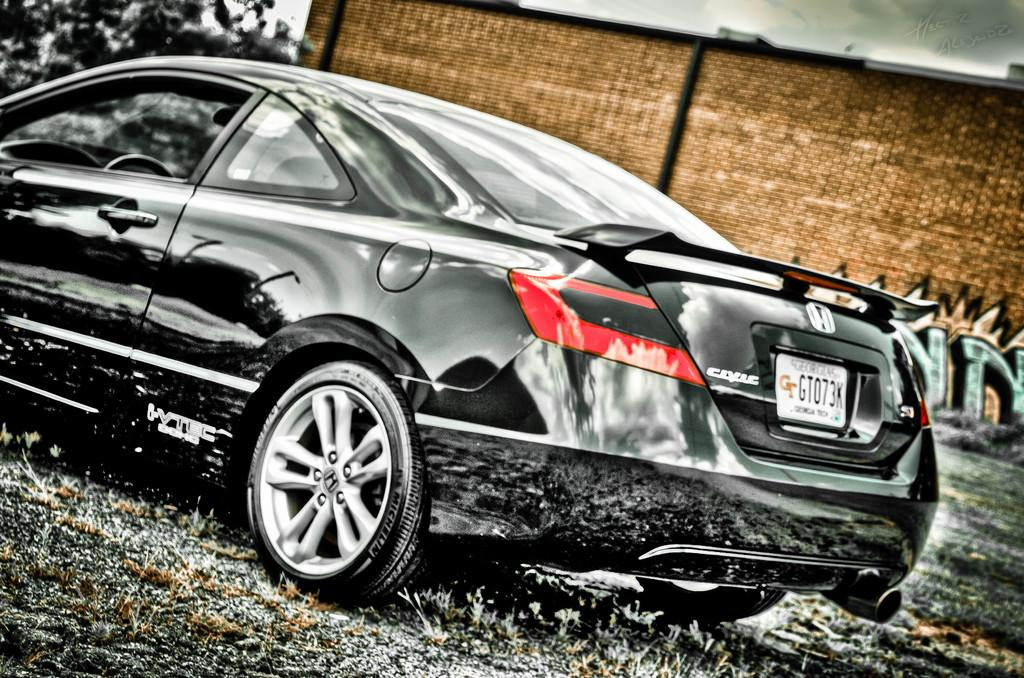What is the main subject in the foreground of the image? There is a car in the foreground of the image. What is the position of the car in relation to the ground? The car is on the ground. What can be seen in the background of the image? There is a wall, a tree, and the sky visible in the background of the image. What type of teeth can be seen in the image? There are no teeth visible in the image; it features a car in the foreground and a wall, tree, and sky in the background. 